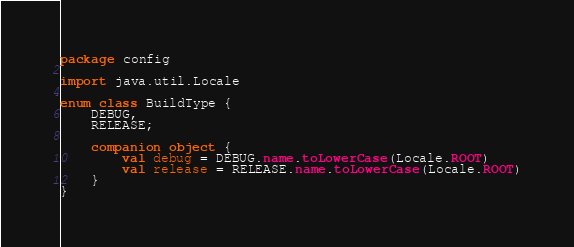<code> <loc_0><loc_0><loc_500><loc_500><_Kotlin_>package config

import java.util.Locale

enum class BuildType {
    DEBUG,
    RELEASE;

    companion object {
        val debug = DEBUG.name.toLowerCase(Locale.ROOT)
        val release = RELEASE.name.toLowerCase(Locale.ROOT)
    }
}
</code> 